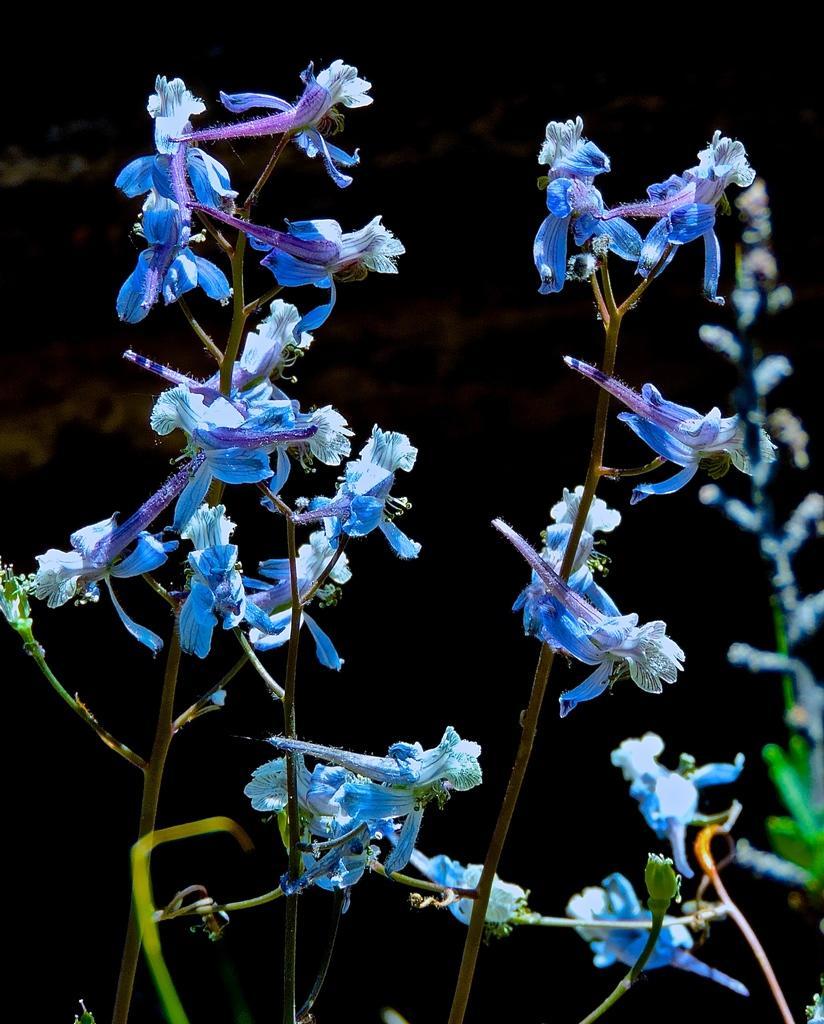Describe this image in one or two sentences. In this picture we can see plants, flowers and in the background it is dark. 